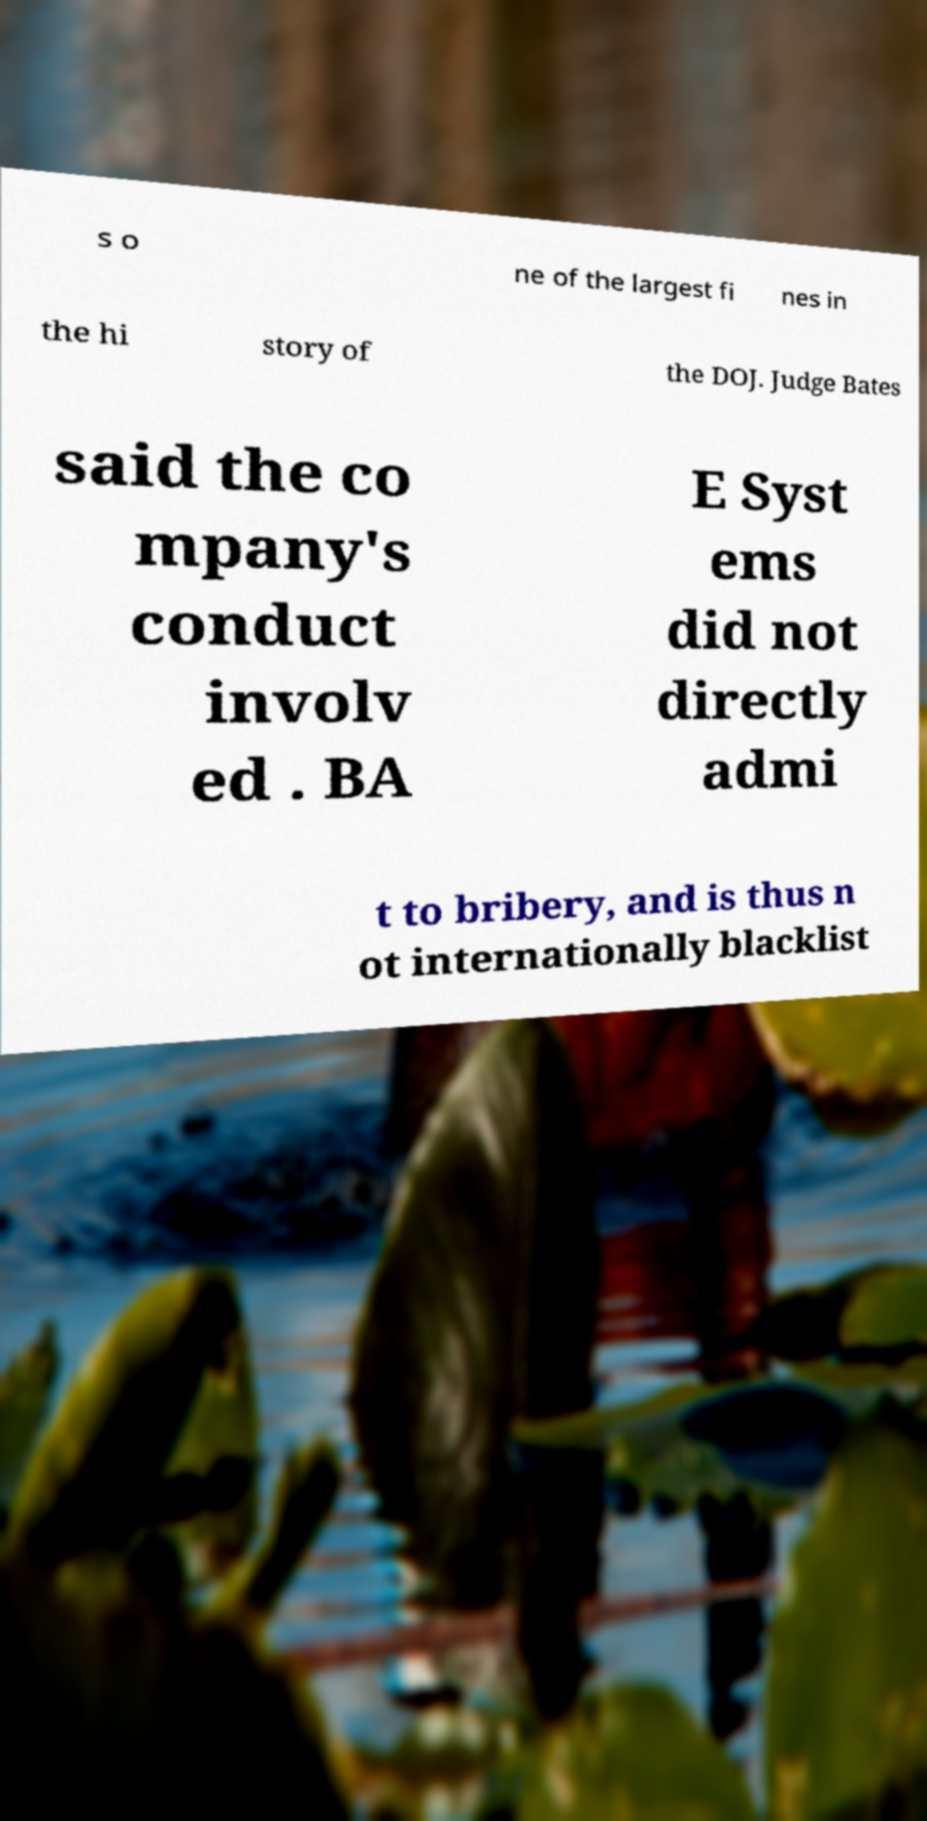Could you assist in decoding the text presented in this image and type it out clearly? s o ne of the largest fi nes in the hi story of the DOJ. Judge Bates said the co mpany's conduct involv ed . BA E Syst ems did not directly admi t to bribery, and is thus n ot internationally blacklist 